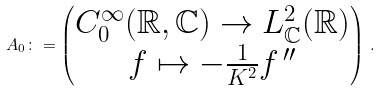<formula> <loc_0><loc_0><loc_500><loc_500>A _ { 0 } \colon = \begin{pmatrix} C _ { 0 } ^ { \infty } ( { \mathbb { R } } , { \mathbb { C } } ) \rightarrow L ^ { 2 } _ { \mathbb { C } } ( { \mathbb { R } } ) \\ f \mapsto - \frac { 1 } { K ^ { 2 } } f ^ { \, \prime \prime } \end{pmatrix} \, .</formula> 